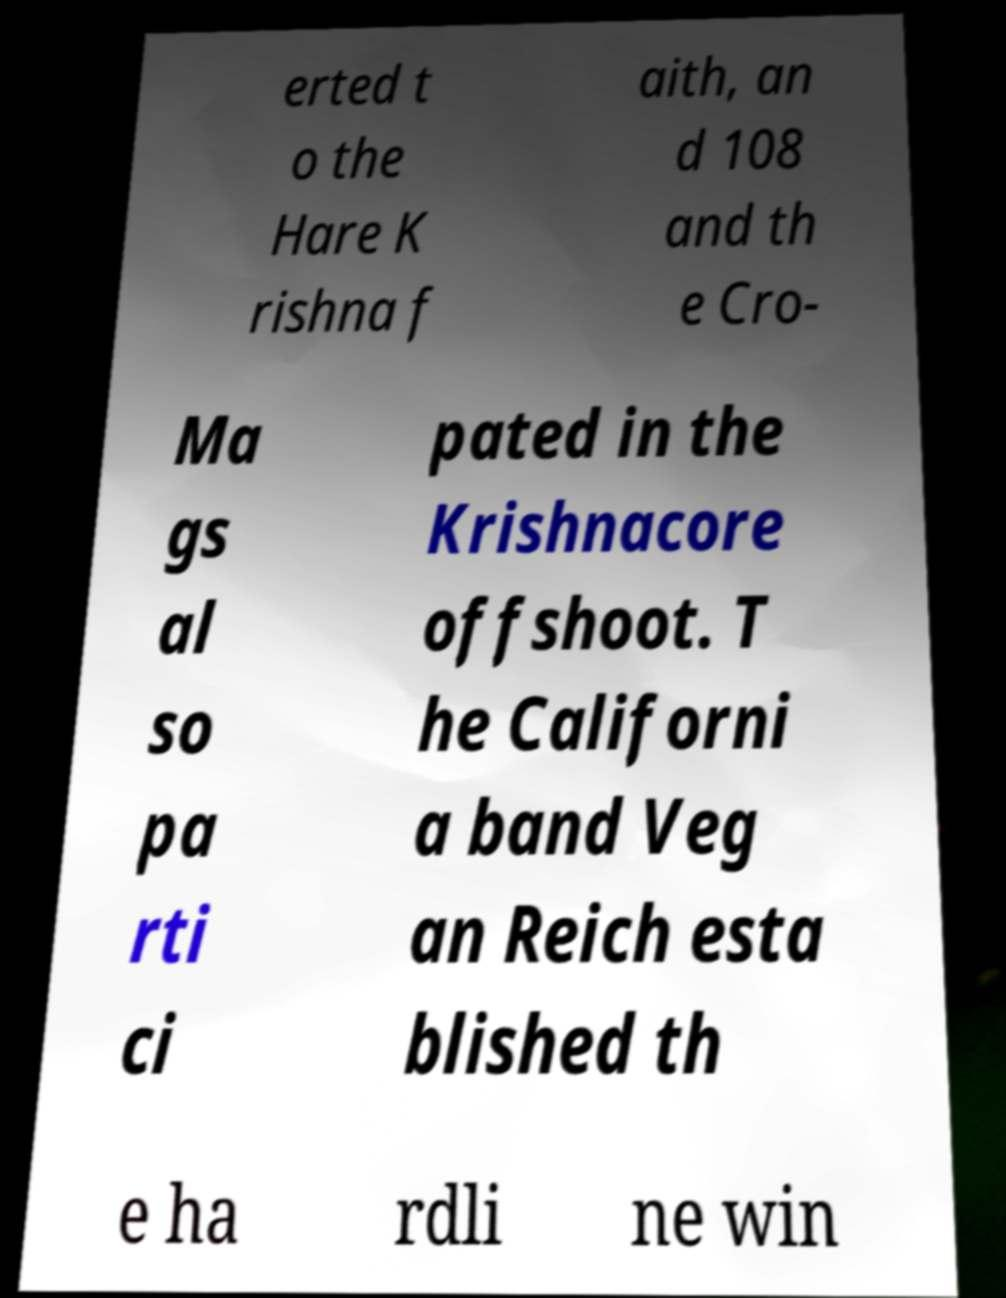Please identify and transcribe the text found in this image. erted t o the Hare K rishna f aith, an d 108 and th e Cro- Ma gs al so pa rti ci pated in the Krishnacore offshoot. T he Californi a band Veg an Reich esta blished th e ha rdli ne win 